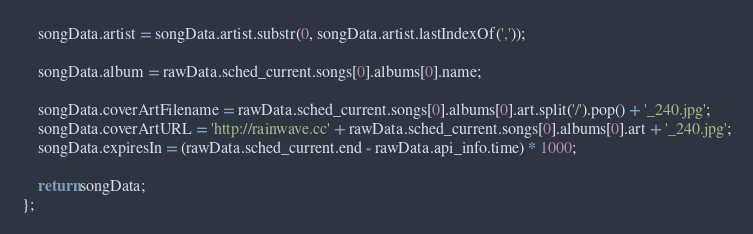<code> <loc_0><loc_0><loc_500><loc_500><_JavaScript_>	songData.artist = songData.artist.substr(0, songData.artist.lastIndexOf(','));

	songData.album = rawData.sched_current.songs[0].albums[0].name;

	songData.coverArtFilename = rawData.sched_current.songs[0].albums[0].art.split('/').pop() + '_240.jpg';
	songData.coverArtURL = 'http://rainwave.cc' + rawData.sched_current.songs[0].albums[0].art + '_240.jpg';
	songData.expiresIn = (rawData.sched_current.end - rawData.api_info.time) * 1000;

	return songData;
};
</code> 